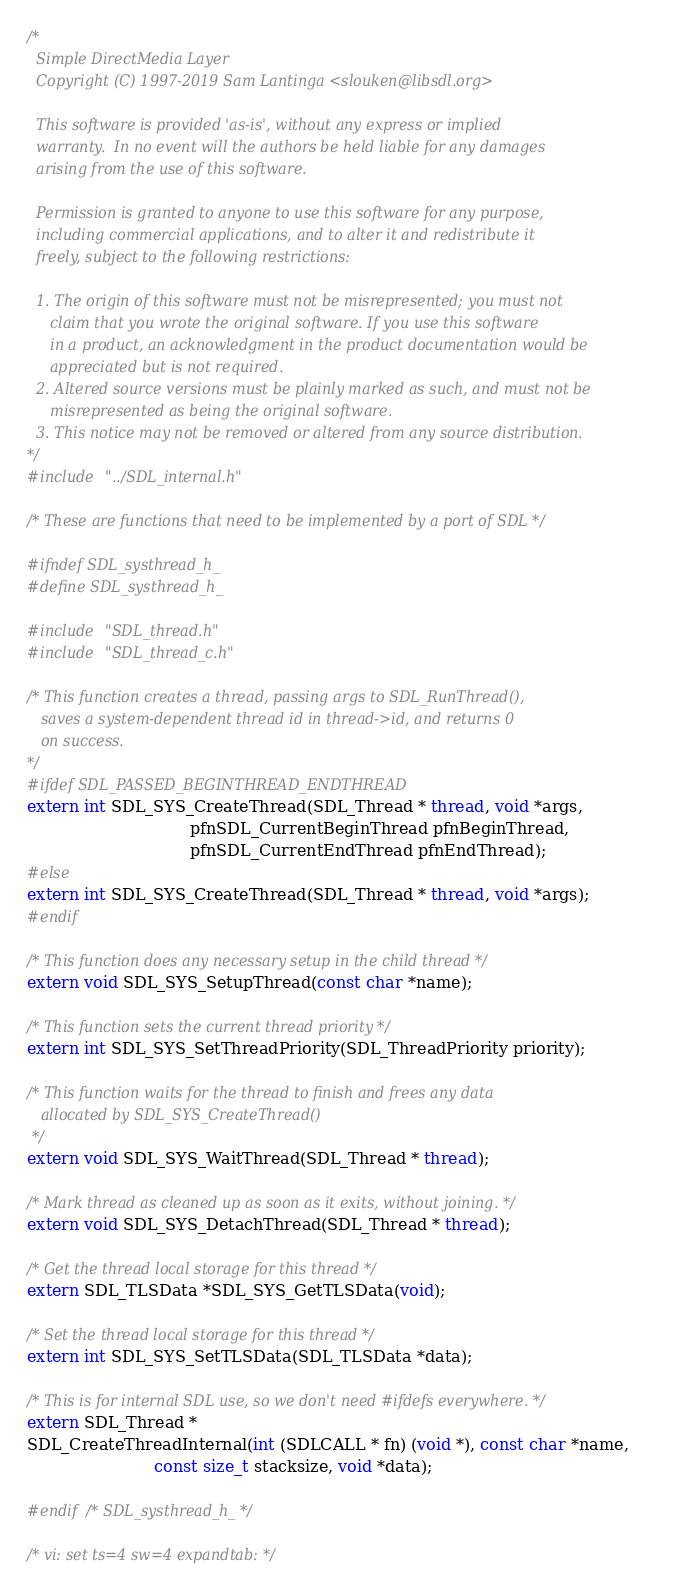Convert code to text. <code><loc_0><loc_0><loc_500><loc_500><_C_>/*
  Simple DirectMedia Layer
  Copyright (C) 1997-2019 Sam Lantinga <slouken@libsdl.org>

  This software is provided 'as-is', without any express or implied
  warranty.  In no event will the authors be held liable for any damages
  arising from the use of this software.

  Permission is granted to anyone to use this software for any purpose,
  including commercial applications, and to alter it and redistribute it
  freely, subject to the following restrictions:

  1. The origin of this software must not be misrepresented; you must not
     claim that you wrote the original software. If you use this software
     in a product, an acknowledgment in the product documentation would be
     appreciated but is not required.
  2. Altered source versions must be plainly marked as such, and must not be
     misrepresented as being the original software.
  3. This notice may not be removed or altered from any source distribution.
*/
#include "../SDL_internal.h"

/* These are functions that need to be implemented by a port of SDL */

#ifndef SDL_systhread_h_
#define SDL_systhread_h_

#include "SDL_thread.h"
#include "SDL_thread_c.h"

/* This function creates a thread, passing args to SDL_RunThread(),
   saves a system-dependent thread id in thread->id, and returns 0
   on success.
*/
#ifdef SDL_PASSED_BEGINTHREAD_ENDTHREAD
extern int SDL_SYS_CreateThread(SDL_Thread * thread, void *args,
                                pfnSDL_CurrentBeginThread pfnBeginThread,
                                pfnSDL_CurrentEndThread pfnEndThread);
#else
extern int SDL_SYS_CreateThread(SDL_Thread * thread, void *args);
#endif

/* This function does any necessary setup in the child thread */
extern void SDL_SYS_SetupThread(const char *name);

/* This function sets the current thread priority */
extern int SDL_SYS_SetThreadPriority(SDL_ThreadPriority priority);

/* This function waits for the thread to finish and frees any data
   allocated by SDL_SYS_CreateThread()
 */
extern void SDL_SYS_WaitThread(SDL_Thread * thread);

/* Mark thread as cleaned up as soon as it exits, without joining. */
extern void SDL_SYS_DetachThread(SDL_Thread * thread);

/* Get the thread local storage for this thread */
extern SDL_TLSData *SDL_SYS_GetTLSData(void);

/* Set the thread local storage for this thread */
extern int SDL_SYS_SetTLSData(SDL_TLSData *data);

/* This is for internal SDL use, so we don't need #ifdefs everywhere. */
extern SDL_Thread *
SDL_CreateThreadInternal(int (SDLCALL * fn) (void *), const char *name,
                         const size_t stacksize, void *data);

#endif /* SDL_systhread_h_ */

/* vi: set ts=4 sw=4 expandtab: */
</code> 